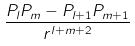Convert formula to latex. <formula><loc_0><loc_0><loc_500><loc_500>\frac { P _ { l } P _ { m } - P _ { l + 1 } P _ { m + 1 } } { r ^ { l + m + 2 } }</formula> 